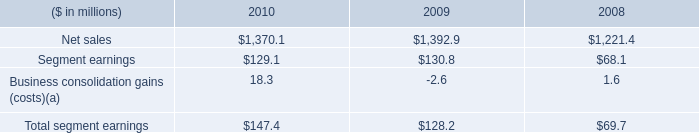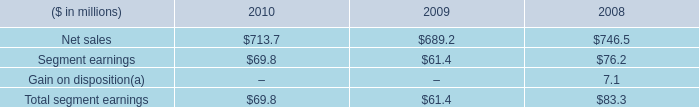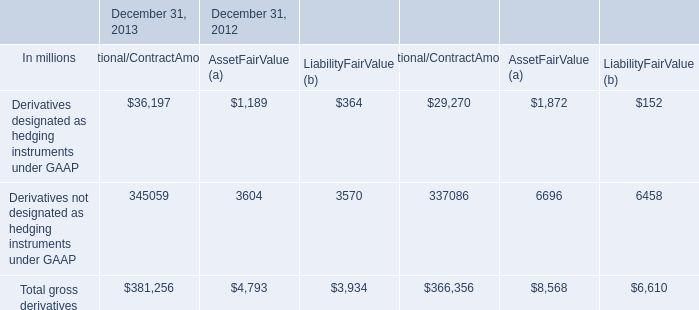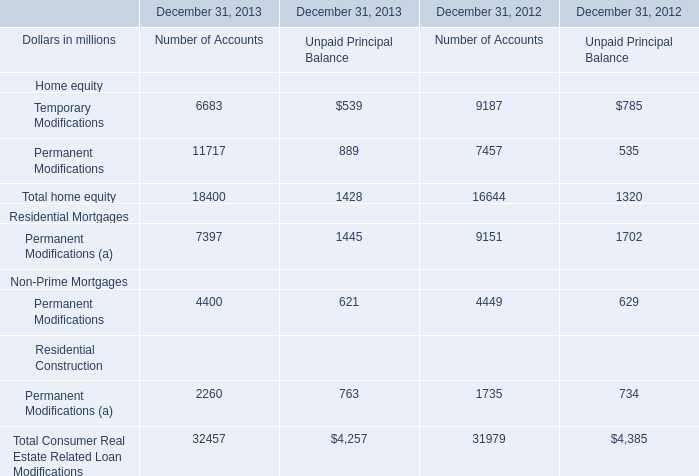What is the average amount of Net sales of 2009, and Permanent Modifications of December 31, 2013 Number of Accounts ? 
Computations: ((1392.9 + 11717.0) / 2)
Answer: 6554.95. 